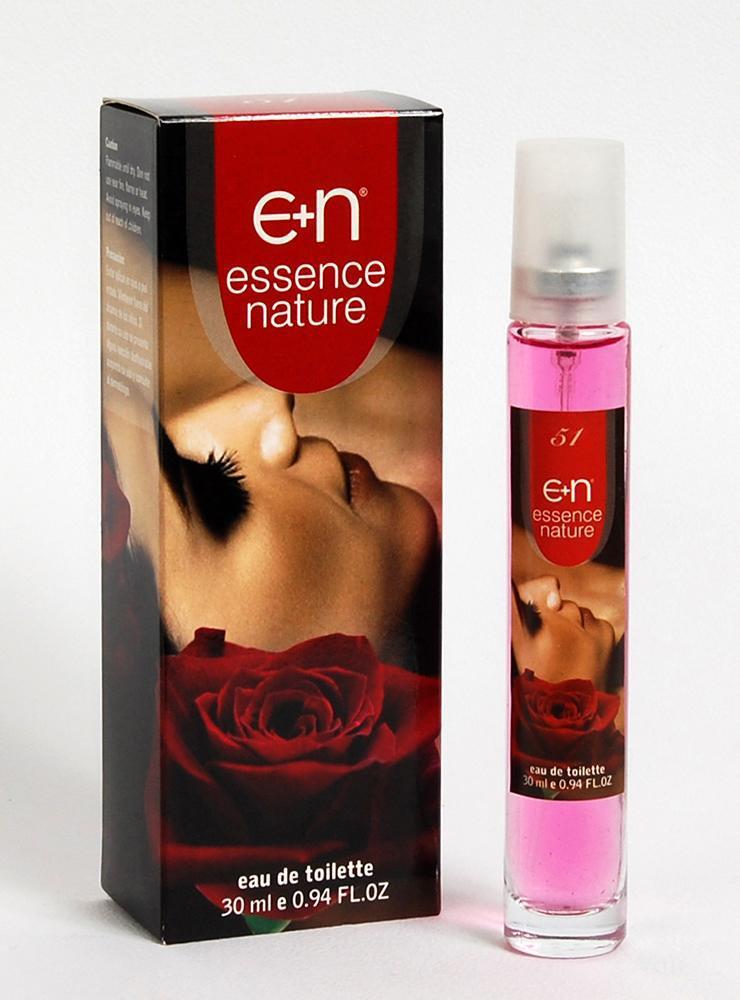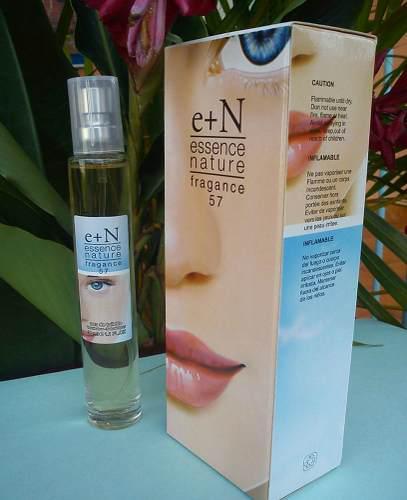The first image is the image on the left, the second image is the image on the right. Considering the images on both sides, is "In one image, a single slender spray bottle stands to the left of a box with a woman's face on it." valid? Answer yes or no. Yes. The first image is the image on the left, the second image is the image on the right. For the images displayed, is the sentence "The right image contains one slim cylinder perfume bottle that is to the left of its packaging case." factually correct? Answer yes or no. Yes. 